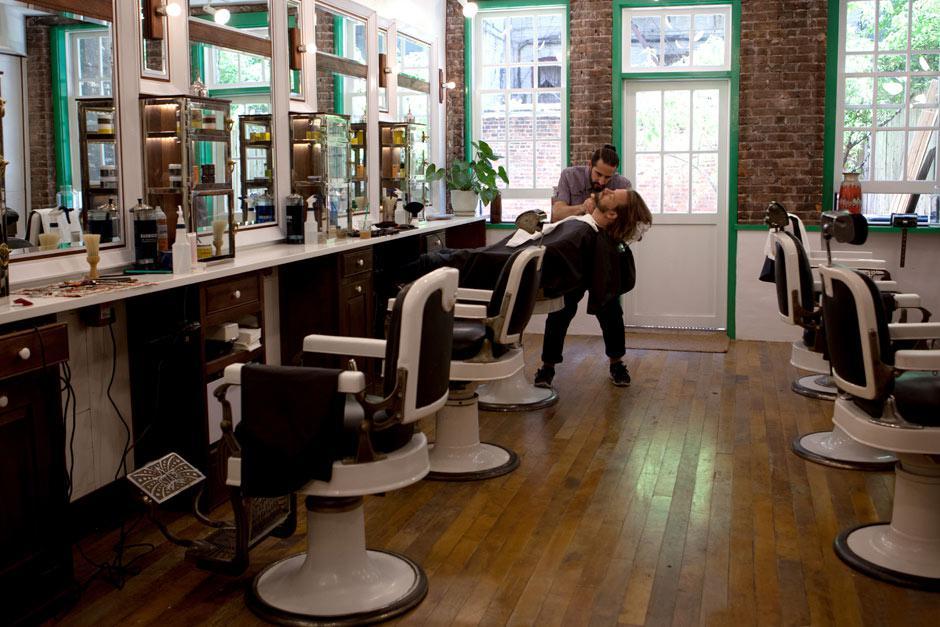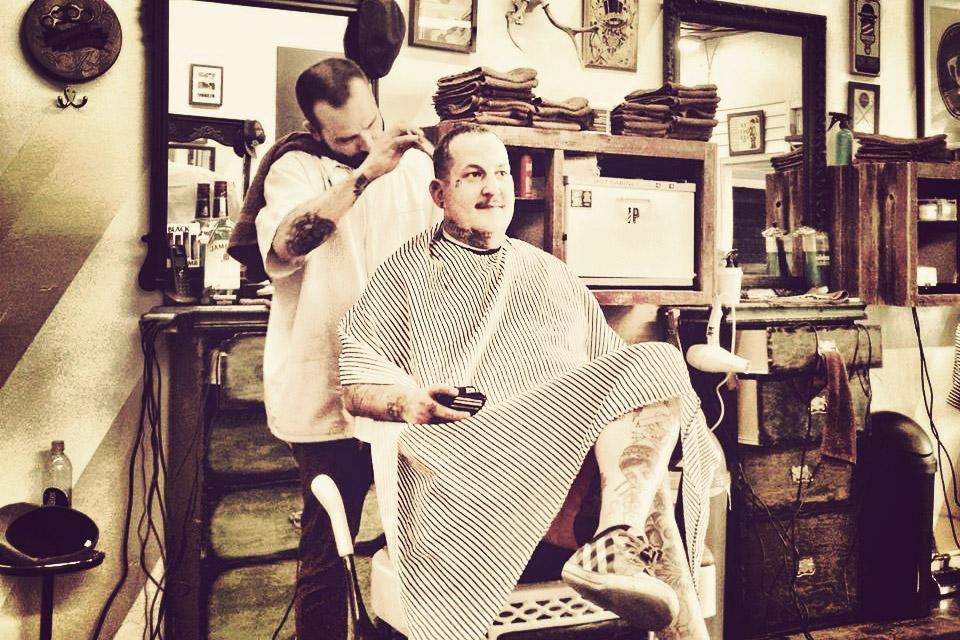The first image is the image on the left, the second image is the image on the right. For the images displayed, is the sentence "The right image shows an empty barber chair turned leftward and facing a horizontal surface piled with items." factually correct? Answer yes or no. No. 